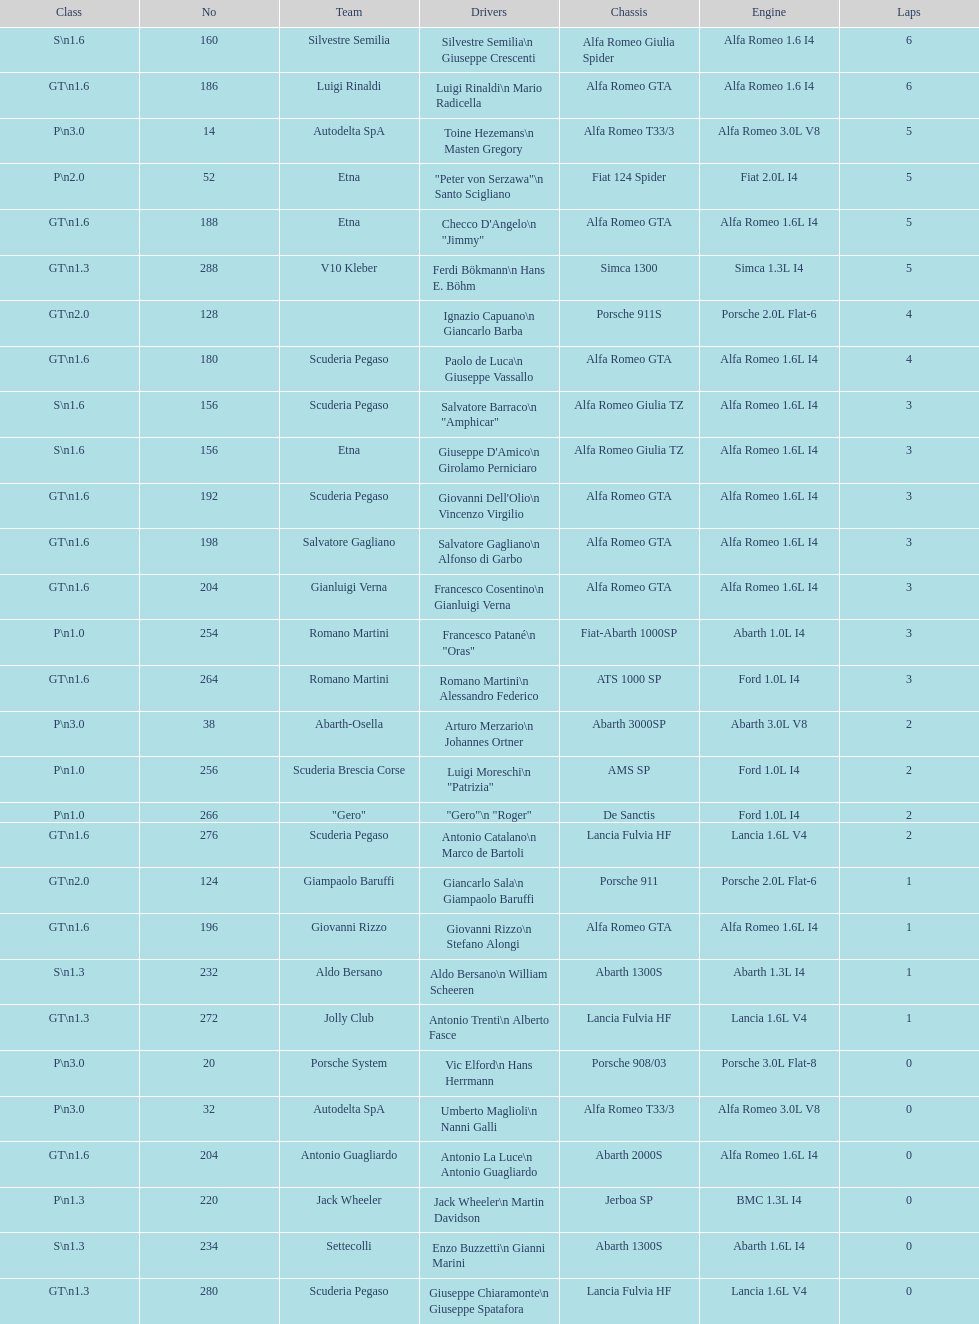Can you give me this table as a dict? {'header': ['Class', 'No', 'Team', 'Drivers', 'Chassis', 'Engine', 'Laps'], 'rows': [['S\\n1.6', '160', 'Silvestre Semilia', 'Silvestre Semilia\\n Giuseppe Crescenti', 'Alfa Romeo Giulia Spider', 'Alfa Romeo 1.6 I4', '6'], ['GT\\n1.6', '186', 'Luigi Rinaldi', 'Luigi Rinaldi\\n Mario Radicella', 'Alfa Romeo GTA', 'Alfa Romeo 1.6 I4', '6'], ['P\\n3.0', '14', 'Autodelta SpA', 'Toine Hezemans\\n Masten Gregory', 'Alfa Romeo T33/3', 'Alfa Romeo 3.0L V8', '5'], ['P\\n2.0', '52', 'Etna', '"Peter von Serzawa"\\n Santo Scigliano', 'Fiat 124 Spider', 'Fiat 2.0L I4', '5'], ['GT\\n1.6', '188', 'Etna', 'Checco D\'Angelo\\n "Jimmy"', 'Alfa Romeo GTA', 'Alfa Romeo 1.6L I4', '5'], ['GT\\n1.3', '288', 'V10 Kleber', 'Ferdi Bökmann\\n Hans E. Böhm', 'Simca 1300', 'Simca 1.3L I4', '5'], ['GT\\n2.0', '128', '', 'Ignazio Capuano\\n Giancarlo Barba', 'Porsche 911S', 'Porsche 2.0L Flat-6', '4'], ['GT\\n1.6', '180', 'Scuderia Pegaso', 'Paolo de Luca\\n Giuseppe Vassallo', 'Alfa Romeo GTA', 'Alfa Romeo 1.6L I4', '4'], ['S\\n1.6', '156', 'Scuderia Pegaso', 'Salvatore Barraco\\n "Amphicar"', 'Alfa Romeo Giulia TZ', 'Alfa Romeo 1.6L I4', '3'], ['S\\n1.6', '156', 'Etna', "Giuseppe D'Amico\\n Girolamo Perniciaro", 'Alfa Romeo Giulia TZ', 'Alfa Romeo 1.6L I4', '3'], ['GT\\n1.6', '192', 'Scuderia Pegaso', "Giovanni Dell'Olio\\n Vincenzo Virgilio", 'Alfa Romeo GTA', 'Alfa Romeo 1.6L I4', '3'], ['GT\\n1.6', '198', 'Salvatore Gagliano', 'Salvatore Gagliano\\n Alfonso di Garbo', 'Alfa Romeo GTA', 'Alfa Romeo 1.6L I4', '3'], ['GT\\n1.6', '204', 'Gianluigi Verna', 'Francesco Cosentino\\n Gianluigi Verna', 'Alfa Romeo GTA', 'Alfa Romeo 1.6L I4', '3'], ['P\\n1.0', '254', 'Romano Martini', 'Francesco Patané\\n "Oras"', 'Fiat-Abarth 1000SP', 'Abarth 1.0L I4', '3'], ['GT\\n1.6', '264', 'Romano Martini', 'Romano Martini\\n Alessandro Federico', 'ATS 1000 SP', 'Ford 1.0L I4', '3'], ['P\\n3.0', '38', 'Abarth-Osella', 'Arturo Merzario\\n Johannes Ortner', 'Abarth 3000SP', 'Abarth 3.0L V8', '2'], ['P\\n1.0', '256', 'Scuderia Brescia Corse', 'Luigi Moreschi\\n "Patrizia"', 'AMS SP', 'Ford 1.0L I4', '2'], ['P\\n1.0', '266', '"Gero"', '"Gero"\\n "Roger"', 'De Sanctis', 'Ford 1.0L I4', '2'], ['GT\\n1.6', '276', 'Scuderia Pegaso', 'Antonio Catalano\\n Marco de Bartoli', 'Lancia Fulvia HF', 'Lancia 1.6L V4', '2'], ['GT\\n2.0', '124', 'Giampaolo Baruffi', 'Giancarlo Sala\\n Giampaolo Baruffi', 'Porsche 911', 'Porsche 2.0L Flat-6', '1'], ['GT\\n1.6', '196', 'Giovanni Rizzo', 'Giovanni Rizzo\\n Stefano Alongi', 'Alfa Romeo GTA', 'Alfa Romeo 1.6L I4', '1'], ['S\\n1.3', '232', 'Aldo Bersano', 'Aldo Bersano\\n William Scheeren', 'Abarth 1300S', 'Abarth 1.3L I4', '1'], ['GT\\n1.3', '272', 'Jolly Club', 'Antonio Trenti\\n Alberto Fasce', 'Lancia Fulvia HF', 'Lancia 1.6L V4', '1'], ['P\\n3.0', '20', 'Porsche System', 'Vic Elford\\n Hans Herrmann', 'Porsche 908/03', 'Porsche 3.0L Flat-8', '0'], ['P\\n3.0', '32', 'Autodelta SpA', 'Umberto Maglioli\\n Nanni Galli', 'Alfa Romeo T33/3', 'Alfa Romeo 3.0L V8', '0'], ['GT\\n1.6', '204', 'Antonio Guagliardo', 'Antonio La Luce\\n Antonio Guagliardo', 'Abarth 2000S', 'Alfa Romeo 1.6L I4', '0'], ['P\\n1.3', '220', 'Jack Wheeler', 'Jack Wheeler\\n Martin Davidson', 'Jerboa SP', 'BMC 1.3L I4', '0'], ['S\\n1.3', '234', 'Settecolli', 'Enzo Buzzetti\\n Gianni Marini', 'Abarth 1300S', 'Abarth 1.6L I4', '0'], ['GT\\n1.3', '280', 'Scuderia Pegaso', 'Giuseppe Chiaramonte\\n Giuseppe Spatafora', 'Lancia Fulvia HF', 'Lancia 1.6L V4', '0']]} How many drivers are from italy? 48. 